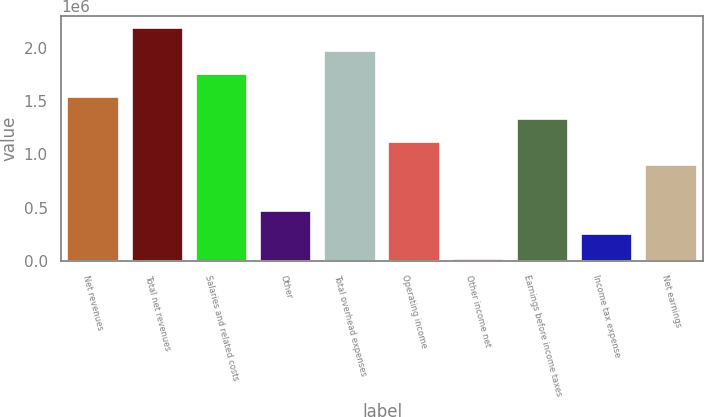<chart> <loc_0><loc_0><loc_500><loc_500><bar_chart><fcel>Net revenues<fcel>Total net revenues<fcel>Salaries and related costs<fcel>Other<fcel>Total overhead expenses<fcel>Operating income<fcel>Other income net<fcel>Earnings before income taxes<fcel>Income tax expense<fcel>Net earnings<nl><fcel>1.54273e+06<fcel>2.18693e+06<fcel>1.75746e+06<fcel>469057<fcel>1.9722e+06<fcel>1.11326e+06<fcel>16693<fcel>1.32799e+06<fcel>254323<fcel>898526<nl></chart> 